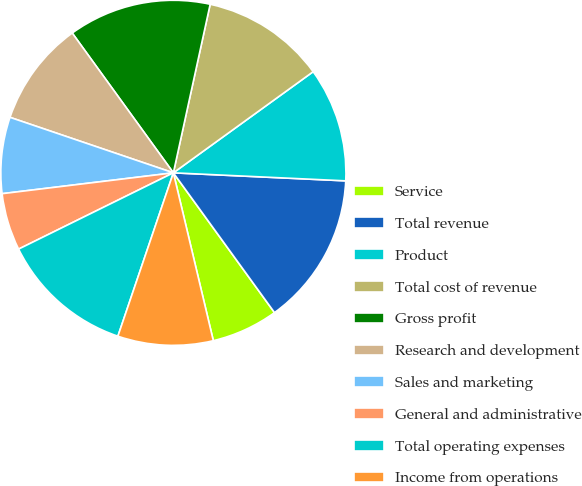Convert chart. <chart><loc_0><loc_0><loc_500><loc_500><pie_chart><fcel>Service<fcel>Total revenue<fcel>Product<fcel>Total cost of revenue<fcel>Gross profit<fcel>Research and development<fcel>Sales and marketing<fcel>General and administrative<fcel>Total operating expenses<fcel>Income from operations<nl><fcel>6.25%<fcel>14.29%<fcel>10.71%<fcel>11.61%<fcel>13.39%<fcel>9.82%<fcel>7.14%<fcel>5.36%<fcel>12.5%<fcel>8.93%<nl></chart> 